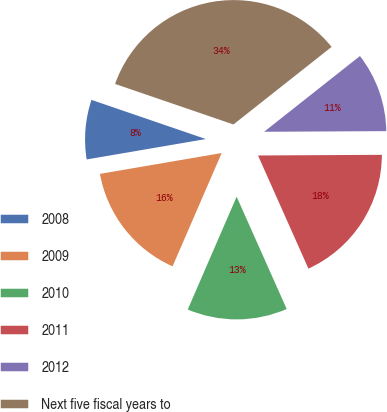Convert chart. <chart><loc_0><loc_0><loc_500><loc_500><pie_chart><fcel>2008<fcel>2009<fcel>2010<fcel>2011<fcel>2012<fcel>Next five fiscal years to<nl><fcel>7.95%<fcel>15.79%<fcel>13.18%<fcel>18.41%<fcel>10.56%<fcel>34.1%<nl></chart> 